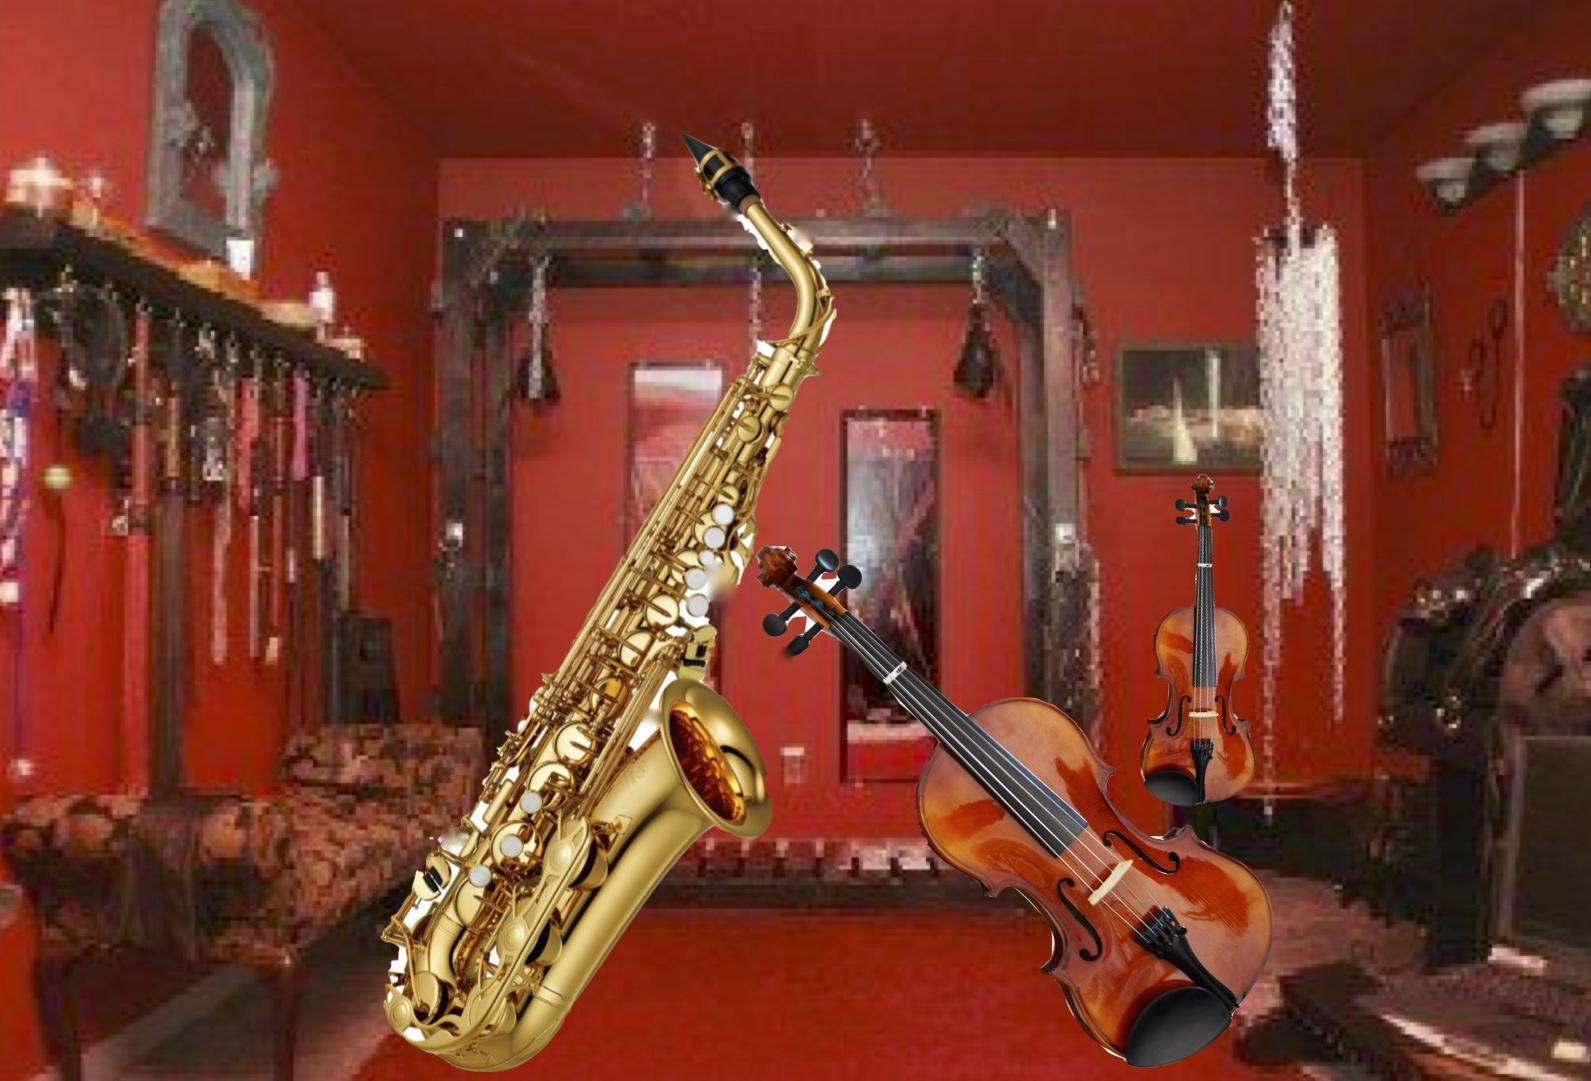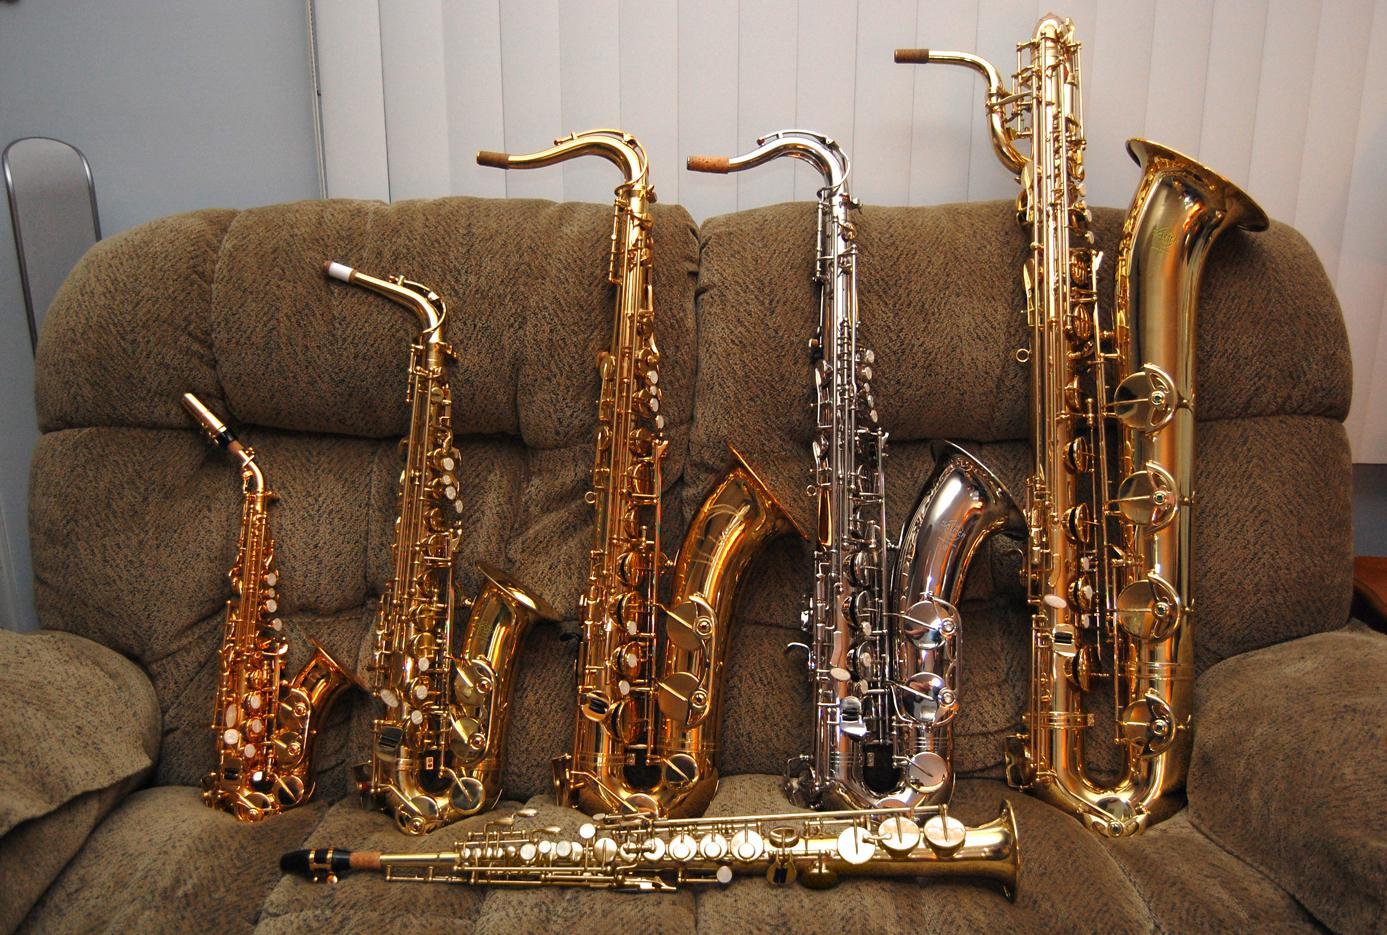The first image is the image on the left, the second image is the image on the right. Analyze the images presented: Is the assertion "Only a single saxophone in each picture." valid? Answer yes or no. No. The first image is the image on the left, the second image is the image on the right. Considering the images on both sides, is "The right image contains a violin, sax and flute." valid? Answer yes or no. No. 